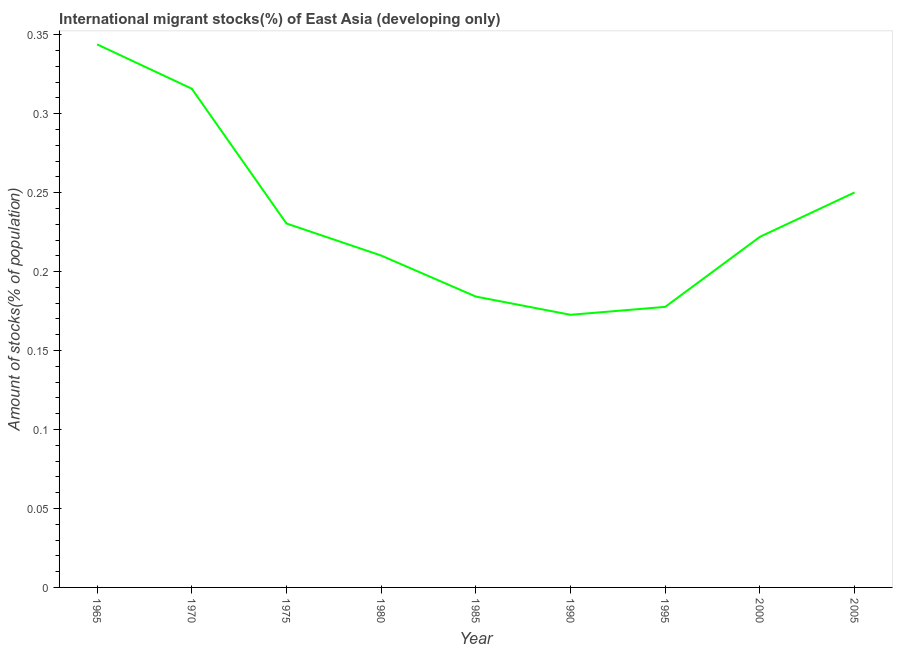What is the number of international migrant stocks in 1980?
Your response must be concise. 0.21. Across all years, what is the maximum number of international migrant stocks?
Your response must be concise. 0.34. Across all years, what is the minimum number of international migrant stocks?
Offer a very short reply. 0.17. In which year was the number of international migrant stocks maximum?
Make the answer very short. 1965. In which year was the number of international migrant stocks minimum?
Ensure brevity in your answer.  1990. What is the sum of the number of international migrant stocks?
Your response must be concise. 2.11. What is the difference between the number of international migrant stocks in 1980 and 1985?
Provide a succinct answer. 0.03. What is the average number of international migrant stocks per year?
Give a very brief answer. 0.23. What is the median number of international migrant stocks?
Your response must be concise. 0.22. In how many years, is the number of international migrant stocks greater than 0.22 %?
Ensure brevity in your answer.  5. Do a majority of the years between 1980 and 1970 (inclusive) have number of international migrant stocks greater than 0.23 %?
Your response must be concise. No. What is the ratio of the number of international migrant stocks in 1975 to that in 1985?
Give a very brief answer. 1.25. Is the number of international migrant stocks in 1990 less than that in 2000?
Your answer should be compact. Yes. What is the difference between the highest and the second highest number of international migrant stocks?
Offer a terse response. 0.03. Is the sum of the number of international migrant stocks in 1970 and 1975 greater than the maximum number of international migrant stocks across all years?
Your response must be concise. Yes. What is the difference between the highest and the lowest number of international migrant stocks?
Offer a terse response. 0.17. In how many years, is the number of international migrant stocks greater than the average number of international migrant stocks taken over all years?
Your answer should be compact. 3. Does the number of international migrant stocks monotonically increase over the years?
Ensure brevity in your answer.  No. What is the difference between two consecutive major ticks on the Y-axis?
Provide a short and direct response. 0.05. Does the graph contain any zero values?
Ensure brevity in your answer.  No. Does the graph contain grids?
Provide a succinct answer. No. What is the title of the graph?
Provide a succinct answer. International migrant stocks(%) of East Asia (developing only). What is the label or title of the Y-axis?
Offer a very short reply. Amount of stocks(% of population). What is the Amount of stocks(% of population) in 1965?
Provide a succinct answer. 0.34. What is the Amount of stocks(% of population) in 1970?
Keep it short and to the point. 0.32. What is the Amount of stocks(% of population) in 1975?
Your answer should be compact. 0.23. What is the Amount of stocks(% of population) in 1980?
Ensure brevity in your answer.  0.21. What is the Amount of stocks(% of population) of 1985?
Make the answer very short. 0.18. What is the Amount of stocks(% of population) of 1990?
Give a very brief answer. 0.17. What is the Amount of stocks(% of population) of 1995?
Make the answer very short. 0.18. What is the Amount of stocks(% of population) of 2000?
Make the answer very short. 0.22. What is the Amount of stocks(% of population) in 2005?
Make the answer very short. 0.25. What is the difference between the Amount of stocks(% of population) in 1965 and 1970?
Provide a short and direct response. 0.03. What is the difference between the Amount of stocks(% of population) in 1965 and 1975?
Give a very brief answer. 0.11. What is the difference between the Amount of stocks(% of population) in 1965 and 1980?
Offer a terse response. 0.13. What is the difference between the Amount of stocks(% of population) in 1965 and 1985?
Your answer should be compact. 0.16. What is the difference between the Amount of stocks(% of population) in 1965 and 1990?
Your response must be concise. 0.17. What is the difference between the Amount of stocks(% of population) in 1965 and 1995?
Your answer should be compact. 0.17. What is the difference between the Amount of stocks(% of population) in 1965 and 2000?
Give a very brief answer. 0.12. What is the difference between the Amount of stocks(% of population) in 1965 and 2005?
Keep it short and to the point. 0.09. What is the difference between the Amount of stocks(% of population) in 1970 and 1975?
Give a very brief answer. 0.09. What is the difference between the Amount of stocks(% of population) in 1970 and 1980?
Make the answer very short. 0.11. What is the difference between the Amount of stocks(% of population) in 1970 and 1985?
Your response must be concise. 0.13. What is the difference between the Amount of stocks(% of population) in 1970 and 1990?
Your response must be concise. 0.14. What is the difference between the Amount of stocks(% of population) in 1970 and 1995?
Keep it short and to the point. 0.14. What is the difference between the Amount of stocks(% of population) in 1970 and 2000?
Make the answer very short. 0.09. What is the difference between the Amount of stocks(% of population) in 1970 and 2005?
Keep it short and to the point. 0.07. What is the difference between the Amount of stocks(% of population) in 1975 and 1980?
Your response must be concise. 0.02. What is the difference between the Amount of stocks(% of population) in 1975 and 1985?
Offer a terse response. 0.05. What is the difference between the Amount of stocks(% of population) in 1975 and 1990?
Keep it short and to the point. 0.06. What is the difference between the Amount of stocks(% of population) in 1975 and 1995?
Your answer should be compact. 0.05. What is the difference between the Amount of stocks(% of population) in 1975 and 2000?
Your answer should be compact. 0.01. What is the difference between the Amount of stocks(% of population) in 1975 and 2005?
Make the answer very short. -0.02. What is the difference between the Amount of stocks(% of population) in 1980 and 1985?
Offer a very short reply. 0.03. What is the difference between the Amount of stocks(% of population) in 1980 and 1990?
Ensure brevity in your answer.  0.04. What is the difference between the Amount of stocks(% of population) in 1980 and 1995?
Offer a terse response. 0.03. What is the difference between the Amount of stocks(% of population) in 1980 and 2000?
Offer a very short reply. -0.01. What is the difference between the Amount of stocks(% of population) in 1980 and 2005?
Ensure brevity in your answer.  -0.04. What is the difference between the Amount of stocks(% of population) in 1985 and 1990?
Keep it short and to the point. 0.01. What is the difference between the Amount of stocks(% of population) in 1985 and 1995?
Make the answer very short. 0.01. What is the difference between the Amount of stocks(% of population) in 1985 and 2000?
Your answer should be compact. -0.04. What is the difference between the Amount of stocks(% of population) in 1985 and 2005?
Give a very brief answer. -0.07. What is the difference between the Amount of stocks(% of population) in 1990 and 1995?
Give a very brief answer. -0.01. What is the difference between the Amount of stocks(% of population) in 1990 and 2000?
Make the answer very short. -0.05. What is the difference between the Amount of stocks(% of population) in 1990 and 2005?
Make the answer very short. -0.08. What is the difference between the Amount of stocks(% of population) in 1995 and 2000?
Your answer should be very brief. -0.04. What is the difference between the Amount of stocks(% of population) in 1995 and 2005?
Offer a very short reply. -0.07. What is the difference between the Amount of stocks(% of population) in 2000 and 2005?
Offer a terse response. -0.03. What is the ratio of the Amount of stocks(% of population) in 1965 to that in 1970?
Provide a succinct answer. 1.09. What is the ratio of the Amount of stocks(% of population) in 1965 to that in 1975?
Provide a succinct answer. 1.49. What is the ratio of the Amount of stocks(% of population) in 1965 to that in 1980?
Keep it short and to the point. 1.64. What is the ratio of the Amount of stocks(% of population) in 1965 to that in 1985?
Offer a terse response. 1.87. What is the ratio of the Amount of stocks(% of population) in 1965 to that in 1990?
Your answer should be very brief. 1.99. What is the ratio of the Amount of stocks(% of population) in 1965 to that in 1995?
Keep it short and to the point. 1.94. What is the ratio of the Amount of stocks(% of population) in 1965 to that in 2000?
Provide a succinct answer. 1.55. What is the ratio of the Amount of stocks(% of population) in 1965 to that in 2005?
Make the answer very short. 1.38. What is the ratio of the Amount of stocks(% of population) in 1970 to that in 1975?
Your answer should be very brief. 1.37. What is the ratio of the Amount of stocks(% of population) in 1970 to that in 1980?
Offer a very short reply. 1.5. What is the ratio of the Amount of stocks(% of population) in 1970 to that in 1985?
Provide a short and direct response. 1.72. What is the ratio of the Amount of stocks(% of population) in 1970 to that in 1990?
Offer a terse response. 1.83. What is the ratio of the Amount of stocks(% of population) in 1970 to that in 1995?
Provide a short and direct response. 1.78. What is the ratio of the Amount of stocks(% of population) in 1970 to that in 2000?
Offer a terse response. 1.42. What is the ratio of the Amount of stocks(% of population) in 1970 to that in 2005?
Make the answer very short. 1.26. What is the ratio of the Amount of stocks(% of population) in 1975 to that in 1980?
Offer a terse response. 1.1. What is the ratio of the Amount of stocks(% of population) in 1975 to that in 1985?
Offer a very short reply. 1.25. What is the ratio of the Amount of stocks(% of population) in 1975 to that in 1990?
Make the answer very short. 1.33. What is the ratio of the Amount of stocks(% of population) in 1975 to that in 1995?
Offer a terse response. 1.3. What is the ratio of the Amount of stocks(% of population) in 1975 to that in 2000?
Provide a short and direct response. 1.04. What is the ratio of the Amount of stocks(% of population) in 1975 to that in 2005?
Ensure brevity in your answer.  0.92. What is the ratio of the Amount of stocks(% of population) in 1980 to that in 1985?
Your answer should be very brief. 1.14. What is the ratio of the Amount of stocks(% of population) in 1980 to that in 1990?
Give a very brief answer. 1.22. What is the ratio of the Amount of stocks(% of population) in 1980 to that in 1995?
Your response must be concise. 1.18. What is the ratio of the Amount of stocks(% of population) in 1980 to that in 2000?
Provide a short and direct response. 0.95. What is the ratio of the Amount of stocks(% of population) in 1980 to that in 2005?
Your answer should be very brief. 0.84. What is the ratio of the Amount of stocks(% of population) in 1985 to that in 1990?
Keep it short and to the point. 1.07. What is the ratio of the Amount of stocks(% of population) in 1985 to that in 1995?
Give a very brief answer. 1.04. What is the ratio of the Amount of stocks(% of population) in 1985 to that in 2000?
Your response must be concise. 0.83. What is the ratio of the Amount of stocks(% of population) in 1985 to that in 2005?
Ensure brevity in your answer.  0.74. What is the ratio of the Amount of stocks(% of population) in 1990 to that in 1995?
Offer a terse response. 0.97. What is the ratio of the Amount of stocks(% of population) in 1990 to that in 2000?
Offer a terse response. 0.78. What is the ratio of the Amount of stocks(% of population) in 1990 to that in 2005?
Provide a succinct answer. 0.69. What is the ratio of the Amount of stocks(% of population) in 1995 to that in 2005?
Offer a very short reply. 0.71. What is the ratio of the Amount of stocks(% of population) in 2000 to that in 2005?
Provide a short and direct response. 0.89. 